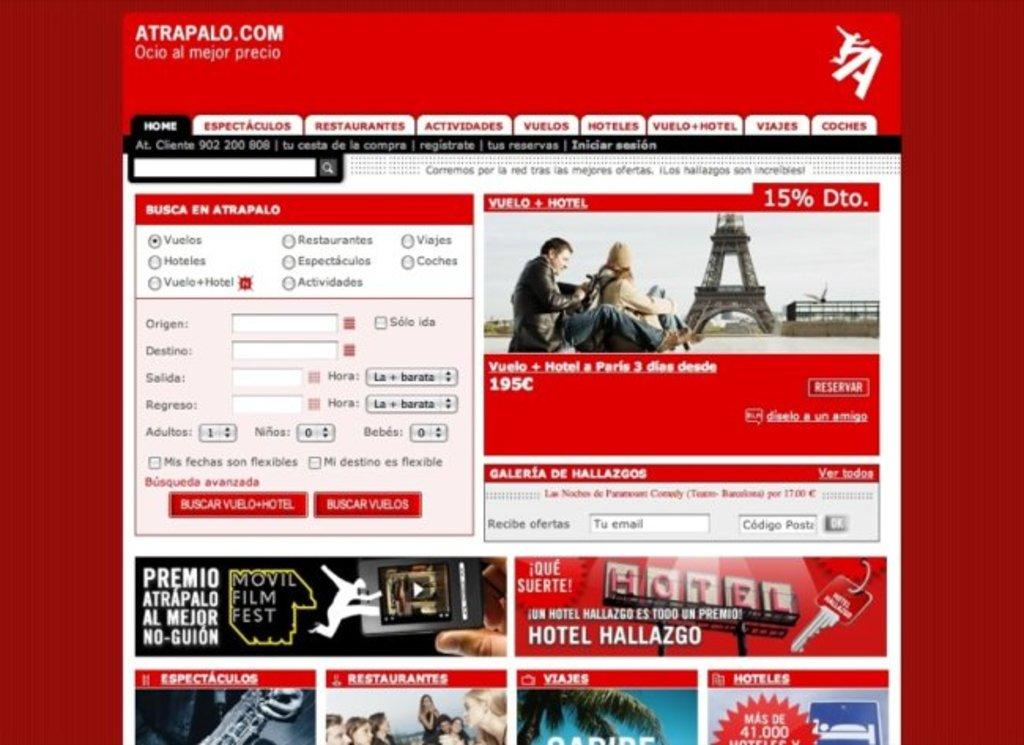What type of content is displayed in the image? The image contains a webpage. What type of hose is being used in the battle depicted on the basketball court in the image? There is no hose, battle, or basketball court present in the image; it contains a webpage. 